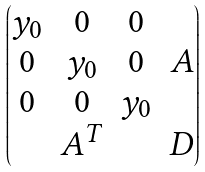<formula> <loc_0><loc_0><loc_500><loc_500>\begin{pmatrix} y _ { 0 } & 0 & 0 & \\ 0 & y _ { 0 } & 0 & A \\ 0 & 0 & y _ { 0 } \\ & A ^ { T } & & D \end{pmatrix}</formula> 